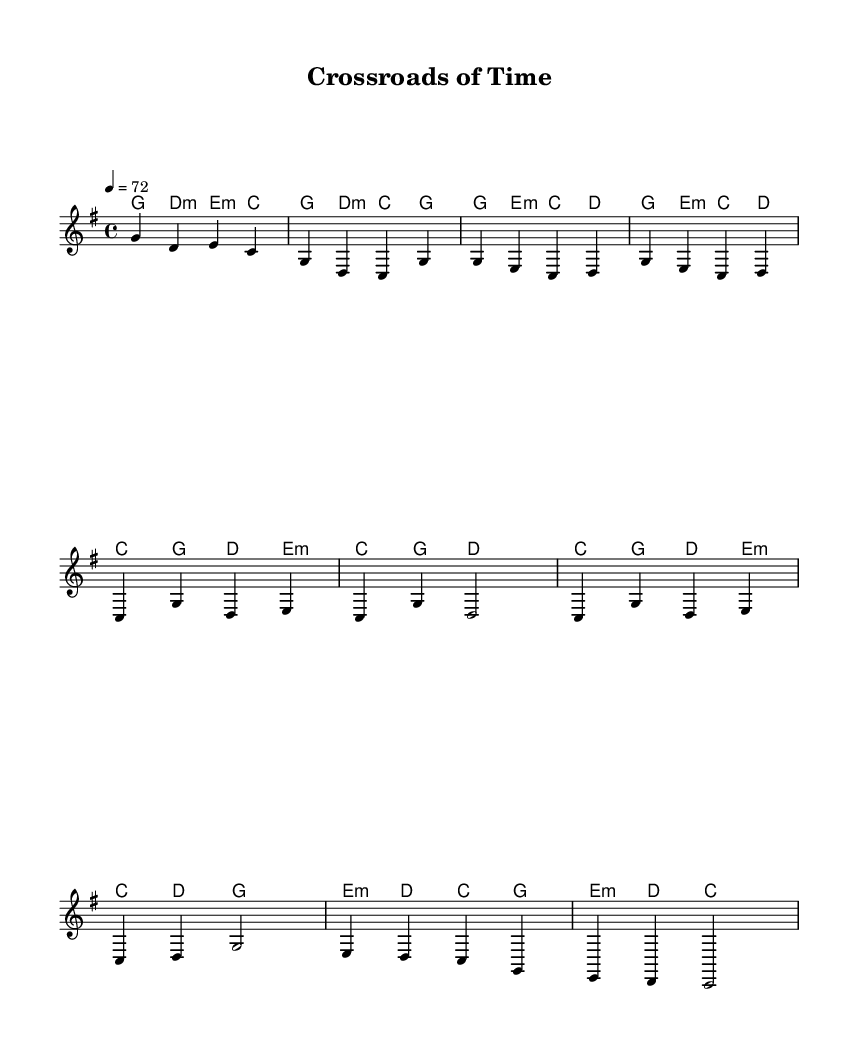What is the key signature of this music? The key signature is G major, which has one sharp. This information can be identified in the global settings of the sheet music, which states \key g \major.
Answer: G major What is the time signature of this music? The time signature is 4/4, which means there are four beats in a measure. This can be determined from the global settings where \time 4/4 is specified.
Answer: 4/4 What is the tempo marking of this music? The tempo marking is 72 beats per minute, as indicated by \tempo 4 = 72 in the global settings. This tells us how fast the music should be played.
Answer: 72 How many measures are in the chorus section? The chorus section has four measures, which can be identified by counting the measures in the chorus part of the melody and harmony.
Answer: 4 What is the lyrical theme of the first verse? The lyrical theme of the first verse focuses on making choices and taking risks, as evidenced by phrases like "Young and bold, I made my choice." This reflects a personal narrative tied to life decisions.
Answer: Choices How do the harmonies change in the bridge compared to the verse? In the bridge, the harmonies shift to emphasize minor chords, such as e:m and d, compared to the verse which primarily utilizes major and minor harmonies. This indicates a different emotional tone.
Answer: Emphasis on minor What unique musical element defines this piece as a Country Rock ballad? The unique musical element is the combination of narrative lyrics with a straightforward harmony and rhythm typical of Country Rock, focusing on the theme of life choices and their consequences.
Answer: Narrative lyrics 